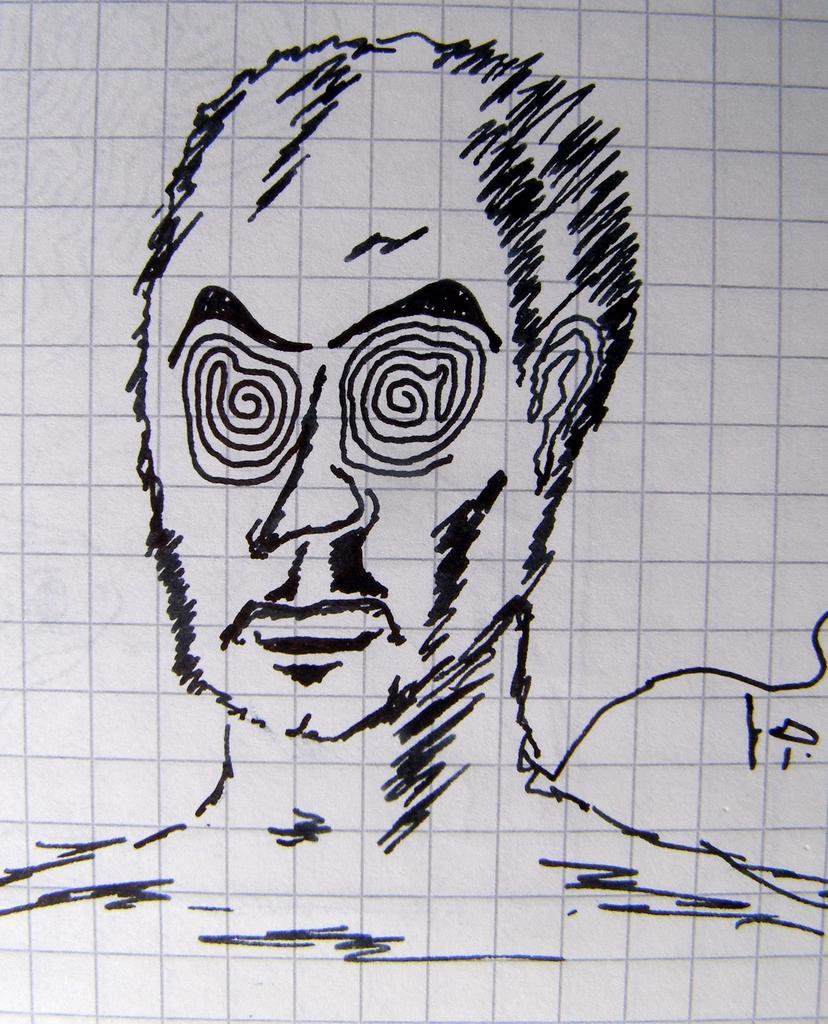Can you describe this image briefly? In this image I can see an art of a person face on the paper and the paper is in white color. 